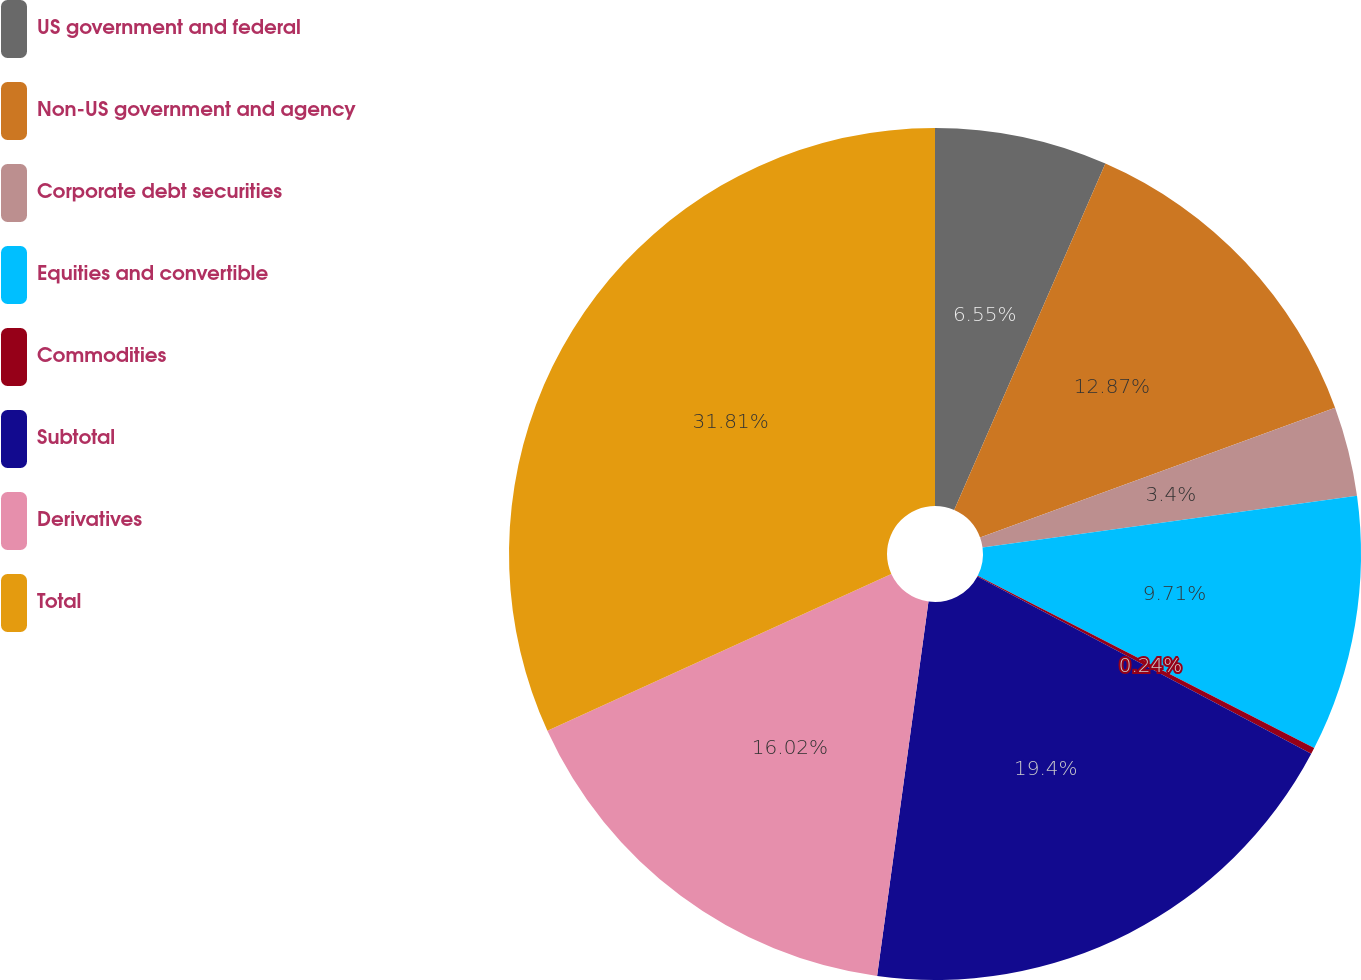<chart> <loc_0><loc_0><loc_500><loc_500><pie_chart><fcel>US government and federal<fcel>Non-US government and agency<fcel>Corporate debt securities<fcel>Equities and convertible<fcel>Commodities<fcel>Subtotal<fcel>Derivatives<fcel>Total<nl><fcel>6.55%<fcel>12.87%<fcel>3.4%<fcel>9.71%<fcel>0.24%<fcel>19.4%<fcel>16.02%<fcel>31.81%<nl></chart> 